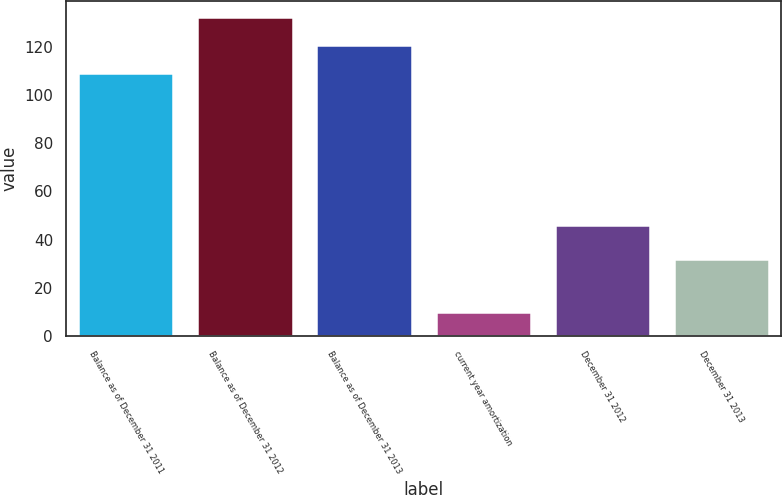<chart> <loc_0><loc_0><loc_500><loc_500><bar_chart><fcel>Balance as of December 31 2011<fcel>Balance as of December 31 2012<fcel>Balance as of December 31 2013<fcel>current year amortization<fcel>December 31 2012<fcel>December 31 2013<nl><fcel>109<fcel>132.2<fcel>120.6<fcel>10<fcel>46<fcel>32<nl></chart> 